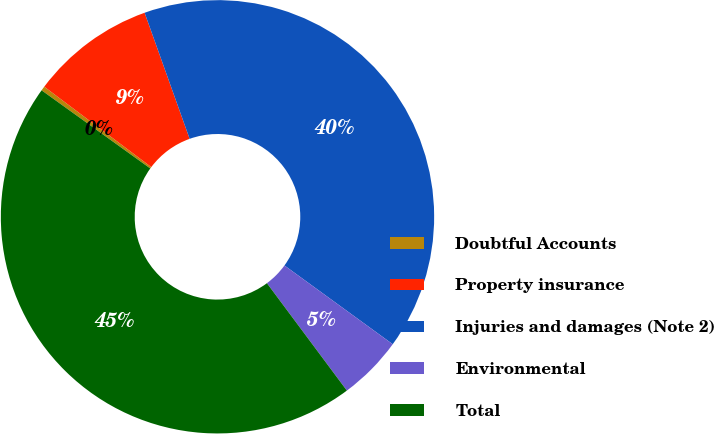Convert chart to OTSL. <chart><loc_0><loc_0><loc_500><loc_500><pie_chart><fcel>Doubtful Accounts<fcel>Property insurance<fcel>Injuries and damages (Note 2)<fcel>Environmental<fcel>Total<nl><fcel>0.33%<fcel>9.29%<fcel>40.47%<fcel>4.81%<fcel>45.11%<nl></chart> 